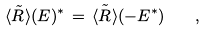Convert formula to latex. <formula><loc_0><loc_0><loc_500><loc_500>\langle \tilde { R } \rangle ( E ) ^ { * } \, = \, \tilde { \langle R \rangle } ( - E ^ { * } ) \quad ,</formula> 